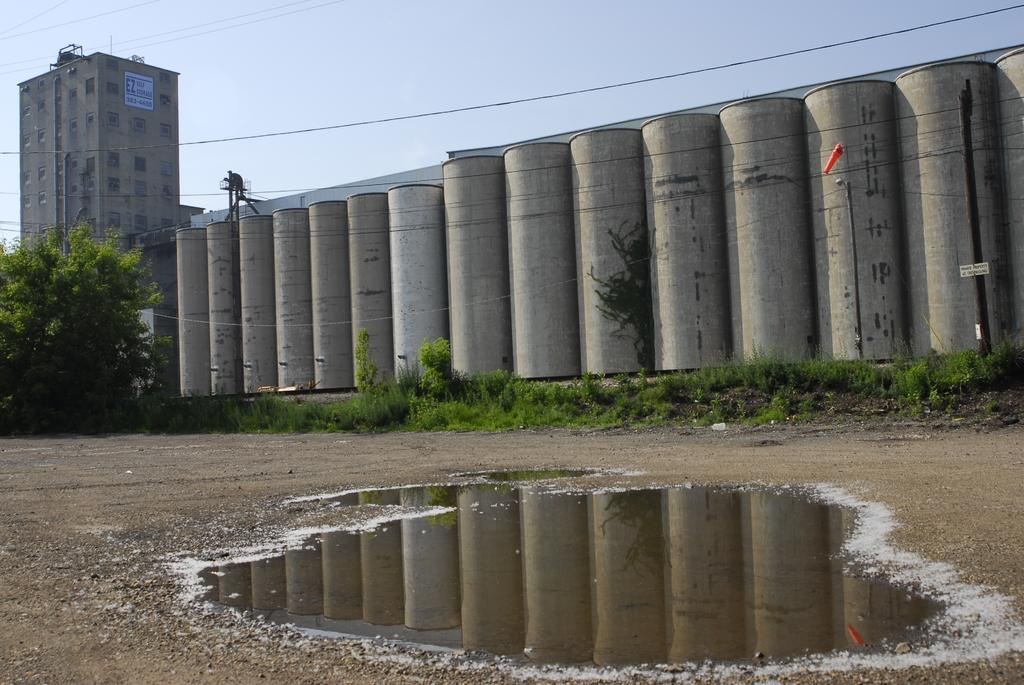What type of structure is visible in the image? There is a building in the image. What other natural elements can be seen in the image? There are trees in the image. What are the poles used for in the image? The purpose of the poles is not specified, but they are visible in the image. What is the condition of the ground in the image? There is water on the ground in the image. What type of containers are present in the image? There are concrete containers in the image. How would you describe the sky in the image? The sky is cloudy in the image. How many kittens are playing with a bone in the image? There are no kittens or bones present in the image. What mathematical operation is being performed on the addition sign in the image? There is no addition sign present in the image. 